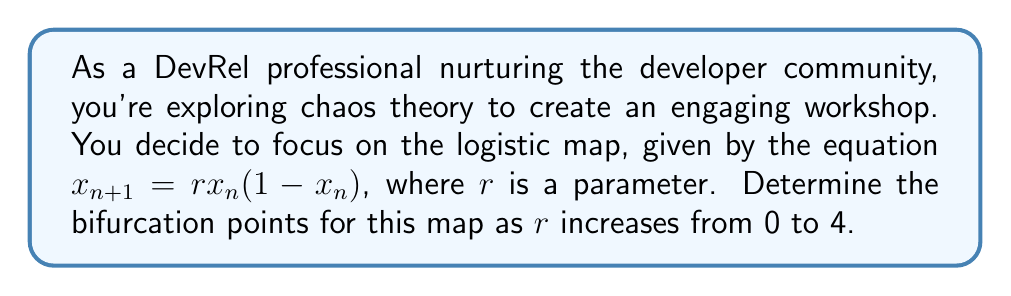Can you answer this question? To find the bifurcation points, we need to analyze the stability of the fixed points and periodic orbits of the logistic map as $r$ varies:

1. Fixed points:
   Solve $x = rx(1-x)$
   $x = 0$ or $x = 1 - \frac{1}{r}$

2. Stability analysis:
   The derivative is $f'(x) = r(1-2x)$

3. Bifurcation points:

   a) $r = 1$: 
      For $r < 1$, $x = 0$ is stable.
      At $r = 1$, $x = 0$ loses stability, and $x = 1 - \frac{1}{r}$ becomes stable.

   b) $r = 3$:
      Solve $|f'(x)| = |-r(1-2x)| = 1$ at $x = 1 - \frac{1}{r}$
      $|-3(1-2(1-\frac{1}{3}))| = |-1| = 1$
      The non-zero fixed point loses stability.

   c) $r \approx 3.45$:
      Period-doubling bifurcation occurs, leading to a 4-cycle.

   d) $r \approx 3.54$:
      Another period-doubling bifurcation, leading to an 8-cycle.

   e) $r \approx 3.57$:
      Onset of chaos, with infinitely many period-doubling bifurcations.

   f) $r = 4$:
      The system becomes fully chaotic.

These bifurcation points represent significant changes in the behavior of the logistic map, which can be visualized using a bifurcation diagram.

[asy]
import graph;
size(200,150);
real f(real x, real r) {return r*x*(1-x);}
for(real r=2.5; r<=4; r+=0.005) {
  real x=0.5;
  for(int i=0; i<100; ++i) {x=f(x,r);}
  for(int i=0; i<100; ++i) {
    x=f(x,r);
    dot((r,x),blue+0.2pt);
  }
}
xaxis("$r$",2.5,4,Arrow);
yaxis("$x$",0,1,Arrow);
label("Bifurcation diagram",point(S),S);
[/asy]
Answer: $r = 1, 3, 3.45, 3.54, 3.57, 4$ 